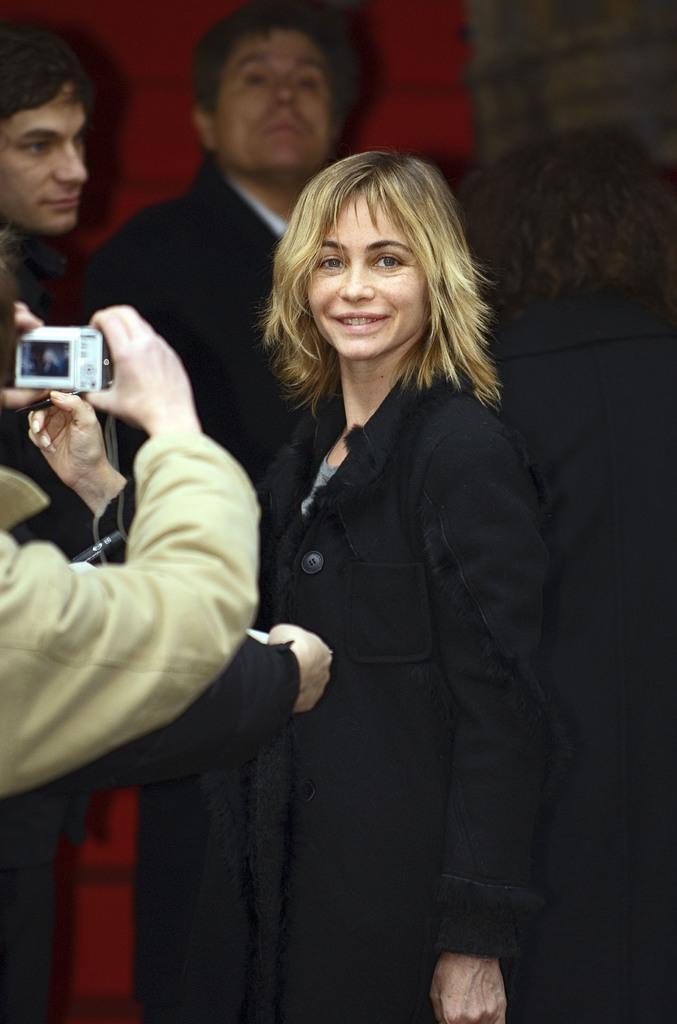Describe this image in one or two sentences. As we can see in the image there are few people over here and the person on the left side is holding a camera. 